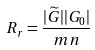Convert formula to latex. <formula><loc_0><loc_0><loc_500><loc_500>R _ { r } = \frac { | \widetilde { G } | | G _ { 0 } | } { m n }</formula> 